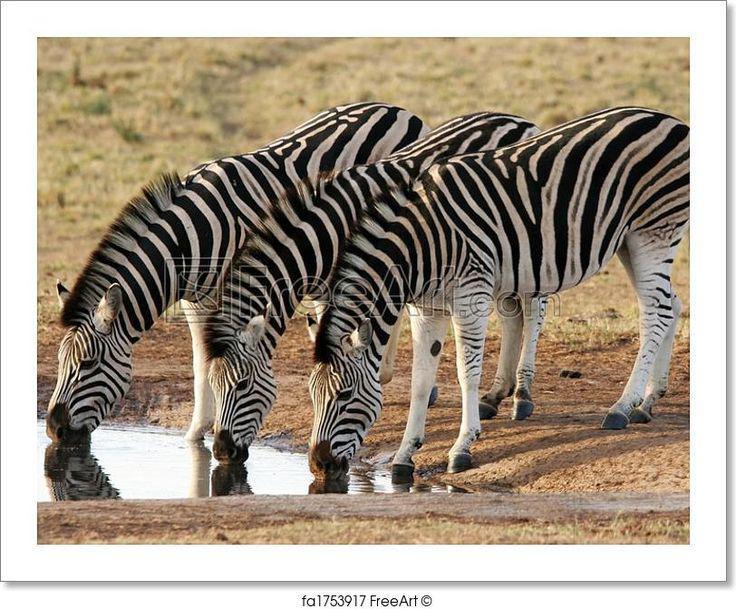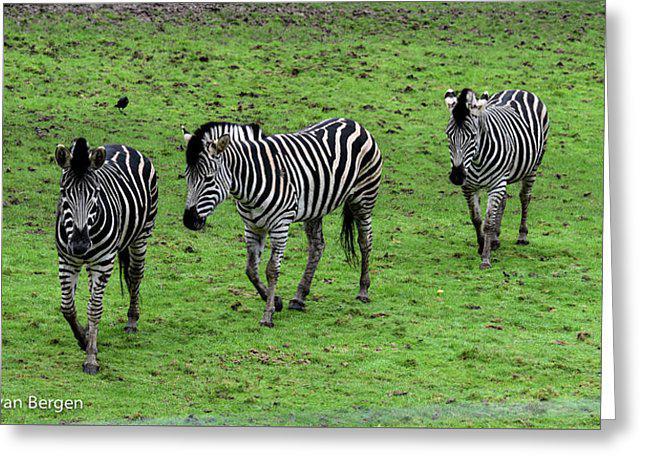The first image is the image on the left, the second image is the image on the right. Assess this claim about the two images: "Three zebras are nicely lined up in both of the pictures.". Correct or not? Answer yes or no. Yes. 